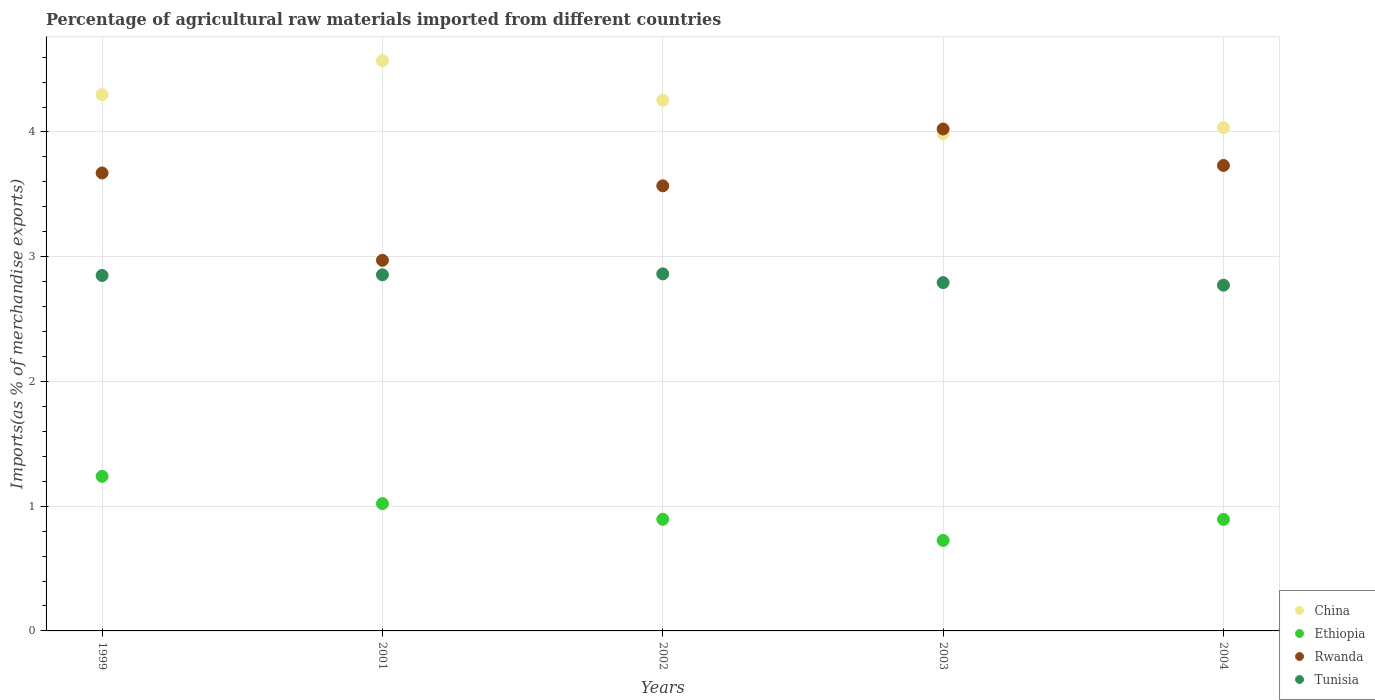How many different coloured dotlines are there?
Offer a very short reply. 4. Is the number of dotlines equal to the number of legend labels?
Provide a succinct answer. Yes. What is the percentage of imports to different countries in China in 2003?
Give a very brief answer. 3.99. Across all years, what is the maximum percentage of imports to different countries in China?
Your response must be concise. 4.57. Across all years, what is the minimum percentage of imports to different countries in Tunisia?
Your answer should be compact. 2.77. In which year was the percentage of imports to different countries in China minimum?
Keep it short and to the point. 2003. What is the total percentage of imports to different countries in Tunisia in the graph?
Give a very brief answer. 14.13. What is the difference between the percentage of imports to different countries in Tunisia in 2001 and that in 2003?
Offer a very short reply. 0.06. What is the difference between the percentage of imports to different countries in Ethiopia in 2003 and the percentage of imports to different countries in Tunisia in 1999?
Keep it short and to the point. -2.12. What is the average percentage of imports to different countries in Rwanda per year?
Your response must be concise. 3.59. In the year 2003, what is the difference between the percentage of imports to different countries in Ethiopia and percentage of imports to different countries in Tunisia?
Provide a short and direct response. -2.07. What is the ratio of the percentage of imports to different countries in Rwanda in 2001 to that in 2004?
Offer a very short reply. 0.8. What is the difference between the highest and the second highest percentage of imports to different countries in Tunisia?
Your response must be concise. 0.01. What is the difference between the highest and the lowest percentage of imports to different countries in Ethiopia?
Make the answer very short. 0.51. Is it the case that in every year, the sum of the percentage of imports to different countries in Tunisia and percentage of imports to different countries in Rwanda  is greater than the percentage of imports to different countries in China?
Your answer should be very brief. Yes. Is the percentage of imports to different countries in Tunisia strictly less than the percentage of imports to different countries in Ethiopia over the years?
Your answer should be compact. No. What is the title of the graph?
Offer a terse response. Percentage of agricultural raw materials imported from different countries. What is the label or title of the Y-axis?
Give a very brief answer. Imports(as % of merchandise exports). What is the Imports(as % of merchandise exports) in China in 1999?
Your answer should be very brief. 4.3. What is the Imports(as % of merchandise exports) in Ethiopia in 1999?
Provide a short and direct response. 1.24. What is the Imports(as % of merchandise exports) of Rwanda in 1999?
Make the answer very short. 3.67. What is the Imports(as % of merchandise exports) in Tunisia in 1999?
Offer a terse response. 2.85. What is the Imports(as % of merchandise exports) in China in 2001?
Make the answer very short. 4.57. What is the Imports(as % of merchandise exports) in Ethiopia in 2001?
Ensure brevity in your answer.  1.02. What is the Imports(as % of merchandise exports) of Rwanda in 2001?
Offer a very short reply. 2.97. What is the Imports(as % of merchandise exports) of Tunisia in 2001?
Keep it short and to the point. 2.85. What is the Imports(as % of merchandise exports) in China in 2002?
Provide a succinct answer. 4.25. What is the Imports(as % of merchandise exports) of Ethiopia in 2002?
Give a very brief answer. 0.89. What is the Imports(as % of merchandise exports) in Rwanda in 2002?
Make the answer very short. 3.57. What is the Imports(as % of merchandise exports) in Tunisia in 2002?
Provide a short and direct response. 2.86. What is the Imports(as % of merchandise exports) in China in 2003?
Give a very brief answer. 3.99. What is the Imports(as % of merchandise exports) in Ethiopia in 2003?
Offer a very short reply. 0.73. What is the Imports(as % of merchandise exports) of Rwanda in 2003?
Offer a terse response. 4.02. What is the Imports(as % of merchandise exports) in Tunisia in 2003?
Your response must be concise. 2.79. What is the Imports(as % of merchandise exports) in China in 2004?
Give a very brief answer. 4.03. What is the Imports(as % of merchandise exports) in Ethiopia in 2004?
Offer a very short reply. 0.89. What is the Imports(as % of merchandise exports) in Rwanda in 2004?
Provide a short and direct response. 3.73. What is the Imports(as % of merchandise exports) in Tunisia in 2004?
Ensure brevity in your answer.  2.77. Across all years, what is the maximum Imports(as % of merchandise exports) in China?
Give a very brief answer. 4.57. Across all years, what is the maximum Imports(as % of merchandise exports) in Ethiopia?
Your answer should be compact. 1.24. Across all years, what is the maximum Imports(as % of merchandise exports) in Rwanda?
Make the answer very short. 4.02. Across all years, what is the maximum Imports(as % of merchandise exports) in Tunisia?
Your answer should be compact. 2.86. Across all years, what is the minimum Imports(as % of merchandise exports) in China?
Provide a succinct answer. 3.99. Across all years, what is the minimum Imports(as % of merchandise exports) in Ethiopia?
Your answer should be compact. 0.73. Across all years, what is the minimum Imports(as % of merchandise exports) of Rwanda?
Provide a succinct answer. 2.97. Across all years, what is the minimum Imports(as % of merchandise exports) in Tunisia?
Your answer should be compact. 2.77. What is the total Imports(as % of merchandise exports) of China in the graph?
Make the answer very short. 21.15. What is the total Imports(as % of merchandise exports) in Ethiopia in the graph?
Give a very brief answer. 4.77. What is the total Imports(as % of merchandise exports) of Rwanda in the graph?
Your response must be concise. 17.97. What is the total Imports(as % of merchandise exports) of Tunisia in the graph?
Give a very brief answer. 14.13. What is the difference between the Imports(as % of merchandise exports) in China in 1999 and that in 2001?
Your answer should be very brief. -0.27. What is the difference between the Imports(as % of merchandise exports) of Ethiopia in 1999 and that in 2001?
Offer a terse response. 0.22. What is the difference between the Imports(as % of merchandise exports) of Rwanda in 1999 and that in 2001?
Your answer should be very brief. 0.7. What is the difference between the Imports(as % of merchandise exports) of Tunisia in 1999 and that in 2001?
Your response must be concise. -0.01. What is the difference between the Imports(as % of merchandise exports) in China in 1999 and that in 2002?
Provide a succinct answer. 0.05. What is the difference between the Imports(as % of merchandise exports) of Ethiopia in 1999 and that in 2002?
Provide a short and direct response. 0.34. What is the difference between the Imports(as % of merchandise exports) in Rwanda in 1999 and that in 2002?
Provide a succinct answer. 0.1. What is the difference between the Imports(as % of merchandise exports) in Tunisia in 1999 and that in 2002?
Give a very brief answer. -0.01. What is the difference between the Imports(as % of merchandise exports) in China in 1999 and that in 2003?
Give a very brief answer. 0.31. What is the difference between the Imports(as % of merchandise exports) of Ethiopia in 1999 and that in 2003?
Give a very brief answer. 0.51. What is the difference between the Imports(as % of merchandise exports) of Rwanda in 1999 and that in 2003?
Make the answer very short. -0.35. What is the difference between the Imports(as % of merchandise exports) of Tunisia in 1999 and that in 2003?
Provide a succinct answer. 0.06. What is the difference between the Imports(as % of merchandise exports) in China in 1999 and that in 2004?
Offer a very short reply. 0.27. What is the difference between the Imports(as % of merchandise exports) in Ethiopia in 1999 and that in 2004?
Your response must be concise. 0.34. What is the difference between the Imports(as % of merchandise exports) of Rwanda in 1999 and that in 2004?
Give a very brief answer. -0.06. What is the difference between the Imports(as % of merchandise exports) in Tunisia in 1999 and that in 2004?
Ensure brevity in your answer.  0.08. What is the difference between the Imports(as % of merchandise exports) of China in 2001 and that in 2002?
Keep it short and to the point. 0.32. What is the difference between the Imports(as % of merchandise exports) of Ethiopia in 2001 and that in 2002?
Offer a very short reply. 0.13. What is the difference between the Imports(as % of merchandise exports) in Rwanda in 2001 and that in 2002?
Provide a short and direct response. -0.6. What is the difference between the Imports(as % of merchandise exports) in Tunisia in 2001 and that in 2002?
Make the answer very short. -0.01. What is the difference between the Imports(as % of merchandise exports) of China in 2001 and that in 2003?
Provide a succinct answer. 0.59. What is the difference between the Imports(as % of merchandise exports) of Ethiopia in 2001 and that in 2003?
Your response must be concise. 0.29. What is the difference between the Imports(as % of merchandise exports) of Rwanda in 2001 and that in 2003?
Your answer should be compact. -1.05. What is the difference between the Imports(as % of merchandise exports) of Tunisia in 2001 and that in 2003?
Give a very brief answer. 0.06. What is the difference between the Imports(as % of merchandise exports) in China in 2001 and that in 2004?
Give a very brief answer. 0.54. What is the difference between the Imports(as % of merchandise exports) in Ethiopia in 2001 and that in 2004?
Your response must be concise. 0.13. What is the difference between the Imports(as % of merchandise exports) in Rwanda in 2001 and that in 2004?
Ensure brevity in your answer.  -0.76. What is the difference between the Imports(as % of merchandise exports) of Tunisia in 2001 and that in 2004?
Offer a very short reply. 0.08. What is the difference between the Imports(as % of merchandise exports) in China in 2002 and that in 2003?
Ensure brevity in your answer.  0.27. What is the difference between the Imports(as % of merchandise exports) of Ethiopia in 2002 and that in 2003?
Offer a terse response. 0.17. What is the difference between the Imports(as % of merchandise exports) in Rwanda in 2002 and that in 2003?
Give a very brief answer. -0.46. What is the difference between the Imports(as % of merchandise exports) in Tunisia in 2002 and that in 2003?
Ensure brevity in your answer.  0.07. What is the difference between the Imports(as % of merchandise exports) of China in 2002 and that in 2004?
Your response must be concise. 0.22. What is the difference between the Imports(as % of merchandise exports) in Ethiopia in 2002 and that in 2004?
Keep it short and to the point. 0. What is the difference between the Imports(as % of merchandise exports) of Rwanda in 2002 and that in 2004?
Keep it short and to the point. -0.16. What is the difference between the Imports(as % of merchandise exports) in Tunisia in 2002 and that in 2004?
Offer a very short reply. 0.09. What is the difference between the Imports(as % of merchandise exports) in China in 2003 and that in 2004?
Offer a terse response. -0.05. What is the difference between the Imports(as % of merchandise exports) of Ethiopia in 2003 and that in 2004?
Offer a very short reply. -0.17. What is the difference between the Imports(as % of merchandise exports) in Rwanda in 2003 and that in 2004?
Your response must be concise. 0.29. What is the difference between the Imports(as % of merchandise exports) in Tunisia in 2003 and that in 2004?
Give a very brief answer. 0.02. What is the difference between the Imports(as % of merchandise exports) in China in 1999 and the Imports(as % of merchandise exports) in Ethiopia in 2001?
Offer a terse response. 3.28. What is the difference between the Imports(as % of merchandise exports) in China in 1999 and the Imports(as % of merchandise exports) in Rwanda in 2001?
Offer a very short reply. 1.33. What is the difference between the Imports(as % of merchandise exports) of China in 1999 and the Imports(as % of merchandise exports) of Tunisia in 2001?
Ensure brevity in your answer.  1.44. What is the difference between the Imports(as % of merchandise exports) of Ethiopia in 1999 and the Imports(as % of merchandise exports) of Rwanda in 2001?
Offer a terse response. -1.73. What is the difference between the Imports(as % of merchandise exports) of Ethiopia in 1999 and the Imports(as % of merchandise exports) of Tunisia in 2001?
Keep it short and to the point. -1.62. What is the difference between the Imports(as % of merchandise exports) in Rwanda in 1999 and the Imports(as % of merchandise exports) in Tunisia in 2001?
Provide a succinct answer. 0.82. What is the difference between the Imports(as % of merchandise exports) of China in 1999 and the Imports(as % of merchandise exports) of Ethiopia in 2002?
Your response must be concise. 3.4. What is the difference between the Imports(as % of merchandise exports) in China in 1999 and the Imports(as % of merchandise exports) in Rwanda in 2002?
Your response must be concise. 0.73. What is the difference between the Imports(as % of merchandise exports) of China in 1999 and the Imports(as % of merchandise exports) of Tunisia in 2002?
Ensure brevity in your answer.  1.44. What is the difference between the Imports(as % of merchandise exports) in Ethiopia in 1999 and the Imports(as % of merchandise exports) in Rwanda in 2002?
Provide a succinct answer. -2.33. What is the difference between the Imports(as % of merchandise exports) of Ethiopia in 1999 and the Imports(as % of merchandise exports) of Tunisia in 2002?
Provide a succinct answer. -1.62. What is the difference between the Imports(as % of merchandise exports) of Rwanda in 1999 and the Imports(as % of merchandise exports) of Tunisia in 2002?
Offer a very short reply. 0.81. What is the difference between the Imports(as % of merchandise exports) of China in 1999 and the Imports(as % of merchandise exports) of Ethiopia in 2003?
Provide a short and direct response. 3.57. What is the difference between the Imports(as % of merchandise exports) in China in 1999 and the Imports(as % of merchandise exports) in Rwanda in 2003?
Your answer should be very brief. 0.28. What is the difference between the Imports(as % of merchandise exports) of China in 1999 and the Imports(as % of merchandise exports) of Tunisia in 2003?
Provide a succinct answer. 1.51. What is the difference between the Imports(as % of merchandise exports) in Ethiopia in 1999 and the Imports(as % of merchandise exports) in Rwanda in 2003?
Your answer should be compact. -2.78. What is the difference between the Imports(as % of merchandise exports) in Ethiopia in 1999 and the Imports(as % of merchandise exports) in Tunisia in 2003?
Provide a short and direct response. -1.55. What is the difference between the Imports(as % of merchandise exports) of Rwanda in 1999 and the Imports(as % of merchandise exports) of Tunisia in 2003?
Your answer should be compact. 0.88. What is the difference between the Imports(as % of merchandise exports) in China in 1999 and the Imports(as % of merchandise exports) in Ethiopia in 2004?
Your answer should be compact. 3.41. What is the difference between the Imports(as % of merchandise exports) in China in 1999 and the Imports(as % of merchandise exports) in Rwanda in 2004?
Give a very brief answer. 0.57. What is the difference between the Imports(as % of merchandise exports) in China in 1999 and the Imports(as % of merchandise exports) in Tunisia in 2004?
Keep it short and to the point. 1.53. What is the difference between the Imports(as % of merchandise exports) of Ethiopia in 1999 and the Imports(as % of merchandise exports) of Rwanda in 2004?
Your answer should be very brief. -2.49. What is the difference between the Imports(as % of merchandise exports) in Ethiopia in 1999 and the Imports(as % of merchandise exports) in Tunisia in 2004?
Ensure brevity in your answer.  -1.53. What is the difference between the Imports(as % of merchandise exports) in Rwanda in 1999 and the Imports(as % of merchandise exports) in Tunisia in 2004?
Give a very brief answer. 0.9. What is the difference between the Imports(as % of merchandise exports) in China in 2001 and the Imports(as % of merchandise exports) in Ethiopia in 2002?
Ensure brevity in your answer.  3.68. What is the difference between the Imports(as % of merchandise exports) in China in 2001 and the Imports(as % of merchandise exports) in Rwanda in 2002?
Ensure brevity in your answer.  1. What is the difference between the Imports(as % of merchandise exports) of China in 2001 and the Imports(as % of merchandise exports) of Tunisia in 2002?
Keep it short and to the point. 1.71. What is the difference between the Imports(as % of merchandise exports) of Ethiopia in 2001 and the Imports(as % of merchandise exports) of Rwanda in 2002?
Ensure brevity in your answer.  -2.55. What is the difference between the Imports(as % of merchandise exports) in Ethiopia in 2001 and the Imports(as % of merchandise exports) in Tunisia in 2002?
Keep it short and to the point. -1.84. What is the difference between the Imports(as % of merchandise exports) of Rwanda in 2001 and the Imports(as % of merchandise exports) of Tunisia in 2002?
Provide a succinct answer. 0.11. What is the difference between the Imports(as % of merchandise exports) in China in 2001 and the Imports(as % of merchandise exports) in Ethiopia in 2003?
Provide a succinct answer. 3.85. What is the difference between the Imports(as % of merchandise exports) of China in 2001 and the Imports(as % of merchandise exports) of Rwanda in 2003?
Ensure brevity in your answer.  0.55. What is the difference between the Imports(as % of merchandise exports) in China in 2001 and the Imports(as % of merchandise exports) in Tunisia in 2003?
Offer a terse response. 1.78. What is the difference between the Imports(as % of merchandise exports) in Ethiopia in 2001 and the Imports(as % of merchandise exports) in Rwanda in 2003?
Keep it short and to the point. -3. What is the difference between the Imports(as % of merchandise exports) in Ethiopia in 2001 and the Imports(as % of merchandise exports) in Tunisia in 2003?
Keep it short and to the point. -1.77. What is the difference between the Imports(as % of merchandise exports) of Rwanda in 2001 and the Imports(as % of merchandise exports) of Tunisia in 2003?
Ensure brevity in your answer.  0.18. What is the difference between the Imports(as % of merchandise exports) in China in 2001 and the Imports(as % of merchandise exports) in Ethiopia in 2004?
Ensure brevity in your answer.  3.68. What is the difference between the Imports(as % of merchandise exports) of China in 2001 and the Imports(as % of merchandise exports) of Rwanda in 2004?
Your answer should be very brief. 0.84. What is the difference between the Imports(as % of merchandise exports) of China in 2001 and the Imports(as % of merchandise exports) of Tunisia in 2004?
Ensure brevity in your answer.  1.8. What is the difference between the Imports(as % of merchandise exports) of Ethiopia in 2001 and the Imports(as % of merchandise exports) of Rwanda in 2004?
Keep it short and to the point. -2.71. What is the difference between the Imports(as % of merchandise exports) of Ethiopia in 2001 and the Imports(as % of merchandise exports) of Tunisia in 2004?
Provide a succinct answer. -1.75. What is the difference between the Imports(as % of merchandise exports) of Rwanda in 2001 and the Imports(as % of merchandise exports) of Tunisia in 2004?
Offer a very short reply. 0.2. What is the difference between the Imports(as % of merchandise exports) in China in 2002 and the Imports(as % of merchandise exports) in Ethiopia in 2003?
Provide a succinct answer. 3.53. What is the difference between the Imports(as % of merchandise exports) of China in 2002 and the Imports(as % of merchandise exports) of Rwanda in 2003?
Your answer should be very brief. 0.23. What is the difference between the Imports(as % of merchandise exports) of China in 2002 and the Imports(as % of merchandise exports) of Tunisia in 2003?
Provide a short and direct response. 1.46. What is the difference between the Imports(as % of merchandise exports) of Ethiopia in 2002 and the Imports(as % of merchandise exports) of Rwanda in 2003?
Your answer should be compact. -3.13. What is the difference between the Imports(as % of merchandise exports) of Ethiopia in 2002 and the Imports(as % of merchandise exports) of Tunisia in 2003?
Ensure brevity in your answer.  -1.9. What is the difference between the Imports(as % of merchandise exports) in Rwanda in 2002 and the Imports(as % of merchandise exports) in Tunisia in 2003?
Offer a very short reply. 0.78. What is the difference between the Imports(as % of merchandise exports) in China in 2002 and the Imports(as % of merchandise exports) in Ethiopia in 2004?
Provide a short and direct response. 3.36. What is the difference between the Imports(as % of merchandise exports) in China in 2002 and the Imports(as % of merchandise exports) in Rwanda in 2004?
Make the answer very short. 0.52. What is the difference between the Imports(as % of merchandise exports) in China in 2002 and the Imports(as % of merchandise exports) in Tunisia in 2004?
Offer a terse response. 1.48. What is the difference between the Imports(as % of merchandise exports) in Ethiopia in 2002 and the Imports(as % of merchandise exports) in Rwanda in 2004?
Provide a short and direct response. -2.84. What is the difference between the Imports(as % of merchandise exports) of Ethiopia in 2002 and the Imports(as % of merchandise exports) of Tunisia in 2004?
Your answer should be very brief. -1.88. What is the difference between the Imports(as % of merchandise exports) of Rwanda in 2002 and the Imports(as % of merchandise exports) of Tunisia in 2004?
Offer a terse response. 0.8. What is the difference between the Imports(as % of merchandise exports) in China in 2003 and the Imports(as % of merchandise exports) in Ethiopia in 2004?
Your answer should be very brief. 3.09. What is the difference between the Imports(as % of merchandise exports) of China in 2003 and the Imports(as % of merchandise exports) of Rwanda in 2004?
Keep it short and to the point. 0.25. What is the difference between the Imports(as % of merchandise exports) in China in 2003 and the Imports(as % of merchandise exports) in Tunisia in 2004?
Your response must be concise. 1.21. What is the difference between the Imports(as % of merchandise exports) of Ethiopia in 2003 and the Imports(as % of merchandise exports) of Rwanda in 2004?
Provide a short and direct response. -3.01. What is the difference between the Imports(as % of merchandise exports) of Ethiopia in 2003 and the Imports(as % of merchandise exports) of Tunisia in 2004?
Provide a short and direct response. -2.05. What is the difference between the Imports(as % of merchandise exports) of Rwanda in 2003 and the Imports(as % of merchandise exports) of Tunisia in 2004?
Provide a short and direct response. 1.25. What is the average Imports(as % of merchandise exports) in China per year?
Give a very brief answer. 4.23. What is the average Imports(as % of merchandise exports) in Ethiopia per year?
Offer a terse response. 0.95. What is the average Imports(as % of merchandise exports) in Rwanda per year?
Give a very brief answer. 3.59. What is the average Imports(as % of merchandise exports) in Tunisia per year?
Your answer should be compact. 2.83. In the year 1999, what is the difference between the Imports(as % of merchandise exports) of China and Imports(as % of merchandise exports) of Ethiopia?
Your answer should be compact. 3.06. In the year 1999, what is the difference between the Imports(as % of merchandise exports) of China and Imports(as % of merchandise exports) of Rwanda?
Provide a succinct answer. 0.63. In the year 1999, what is the difference between the Imports(as % of merchandise exports) of China and Imports(as % of merchandise exports) of Tunisia?
Your answer should be very brief. 1.45. In the year 1999, what is the difference between the Imports(as % of merchandise exports) of Ethiopia and Imports(as % of merchandise exports) of Rwanda?
Your response must be concise. -2.43. In the year 1999, what is the difference between the Imports(as % of merchandise exports) in Ethiopia and Imports(as % of merchandise exports) in Tunisia?
Your answer should be compact. -1.61. In the year 1999, what is the difference between the Imports(as % of merchandise exports) of Rwanda and Imports(as % of merchandise exports) of Tunisia?
Your answer should be compact. 0.82. In the year 2001, what is the difference between the Imports(as % of merchandise exports) in China and Imports(as % of merchandise exports) in Ethiopia?
Provide a short and direct response. 3.55. In the year 2001, what is the difference between the Imports(as % of merchandise exports) of China and Imports(as % of merchandise exports) of Rwanda?
Give a very brief answer. 1.6. In the year 2001, what is the difference between the Imports(as % of merchandise exports) in China and Imports(as % of merchandise exports) in Tunisia?
Ensure brevity in your answer.  1.72. In the year 2001, what is the difference between the Imports(as % of merchandise exports) in Ethiopia and Imports(as % of merchandise exports) in Rwanda?
Make the answer very short. -1.95. In the year 2001, what is the difference between the Imports(as % of merchandise exports) in Ethiopia and Imports(as % of merchandise exports) in Tunisia?
Your answer should be compact. -1.83. In the year 2001, what is the difference between the Imports(as % of merchandise exports) of Rwanda and Imports(as % of merchandise exports) of Tunisia?
Make the answer very short. 0.12. In the year 2002, what is the difference between the Imports(as % of merchandise exports) of China and Imports(as % of merchandise exports) of Ethiopia?
Keep it short and to the point. 3.36. In the year 2002, what is the difference between the Imports(as % of merchandise exports) of China and Imports(as % of merchandise exports) of Rwanda?
Provide a short and direct response. 0.69. In the year 2002, what is the difference between the Imports(as % of merchandise exports) in China and Imports(as % of merchandise exports) in Tunisia?
Provide a succinct answer. 1.39. In the year 2002, what is the difference between the Imports(as % of merchandise exports) of Ethiopia and Imports(as % of merchandise exports) of Rwanda?
Ensure brevity in your answer.  -2.67. In the year 2002, what is the difference between the Imports(as % of merchandise exports) in Ethiopia and Imports(as % of merchandise exports) in Tunisia?
Your answer should be compact. -1.97. In the year 2002, what is the difference between the Imports(as % of merchandise exports) of Rwanda and Imports(as % of merchandise exports) of Tunisia?
Make the answer very short. 0.71. In the year 2003, what is the difference between the Imports(as % of merchandise exports) of China and Imports(as % of merchandise exports) of Ethiopia?
Provide a succinct answer. 3.26. In the year 2003, what is the difference between the Imports(as % of merchandise exports) of China and Imports(as % of merchandise exports) of Rwanda?
Your answer should be compact. -0.04. In the year 2003, what is the difference between the Imports(as % of merchandise exports) of China and Imports(as % of merchandise exports) of Tunisia?
Ensure brevity in your answer.  1.19. In the year 2003, what is the difference between the Imports(as % of merchandise exports) in Ethiopia and Imports(as % of merchandise exports) in Rwanda?
Give a very brief answer. -3.3. In the year 2003, what is the difference between the Imports(as % of merchandise exports) in Ethiopia and Imports(as % of merchandise exports) in Tunisia?
Offer a terse response. -2.07. In the year 2003, what is the difference between the Imports(as % of merchandise exports) of Rwanda and Imports(as % of merchandise exports) of Tunisia?
Provide a succinct answer. 1.23. In the year 2004, what is the difference between the Imports(as % of merchandise exports) of China and Imports(as % of merchandise exports) of Ethiopia?
Offer a terse response. 3.14. In the year 2004, what is the difference between the Imports(as % of merchandise exports) in China and Imports(as % of merchandise exports) in Rwanda?
Provide a succinct answer. 0.3. In the year 2004, what is the difference between the Imports(as % of merchandise exports) in China and Imports(as % of merchandise exports) in Tunisia?
Your response must be concise. 1.26. In the year 2004, what is the difference between the Imports(as % of merchandise exports) of Ethiopia and Imports(as % of merchandise exports) of Rwanda?
Offer a very short reply. -2.84. In the year 2004, what is the difference between the Imports(as % of merchandise exports) in Ethiopia and Imports(as % of merchandise exports) in Tunisia?
Your answer should be compact. -1.88. In the year 2004, what is the difference between the Imports(as % of merchandise exports) in Rwanda and Imports(as % of merchandise exports) in Tunisia?
Your answer should be compact. 0.96. What is the ratio of the Imports(as % of merchandise exports) in China in 1999 to that in 2001?
Offer a very short reply. 0.94. What is the ratio of the Imports(as % of merchandise exports) in Ethiopia in 1999 to that in 2001?
Your answer should be very brief. 1.21. What is the ratio of the Imports(as % of merchandise exports) in Rwanda in 1999 to that in 2001?
Provide a succinct answer. 1.24. What is the ratio of the Imports(as % of merchandise exports) in China in 1999 to that in 2002?
Make the answer very short. 1.01. What is the ratio of the Imports(as % of merchandise exports) of Ethiopia in 1999 to that in 2002?
Offer a very short reply. 1.38. What is the ratio of the Imports(as % of merchandise exports) of Rwanda in 1999 to that in 2002?
Make the answer very short. 1.03. What is the ratio of the Imports(as % of merchandise exports) of Tunisia in 1999 to that in 2002?
Ensure brevity in your answer.  1. What is the ratio of the Imports(as % of merchandise exports) in China in 1999 to that in 2003?
Offer a very short reply. 1.08. What is the ratio of the Imports(as % of merchandise exports) of Ethiopia in 1999 to that in 2003?
Provide a short and direct response. 1.71. What is the ratio of the Imports(as % of merchandise exports) of Rwanda in 1999 to that in 2003?
Your response must be concise. 0.91. What is the ratio of the Imports(as % of merchandise exports) in Tunisia in 1999 to that in 2003?
Your answer should be very brief. 1.02. What is the ratio of the Imports(as % of merchandise exports) in China in 1999 to that in 2004?
Make the answer very short. 1.07. What is the ratio of the Imports(as % of merchandise exports) in Ethiopia in 1999 to that in 2004?
Provide a succinct answer. 1.39. What is the ratio of the Imports(as % of merchandise exports) in Rwanda in 1999 to that in 2004?
Provide a succinct answer. 0.98. What is the ratio of the Imports(as % of merchandise exports) in Tunisia in 1999 to that in 2004?
Offer a very short reply. 1.03. What is the ratio of the Imports(as % of merchandise exports) in China in 2001 to that in 2002?
Offer a very short reply. 1.07. What is the ratio of the Imports(as % of merchandise exports) in Ethiopia in 2001 to that in 2002?
Offer a very short reply. 1.14. What is the ratio of the Imports(as % of merchandise exports) in Rwanda in 2001 to that in 2002?
Your response must be concise. 0.83. What is the ratio of the Imports(as % of merchandise exports) in China in 2001 to that in 2003?
Offer a terse response. 1.15. What is the ratio of the Imports(as % of merchandise exports) of Ethiopia in 2001 to that in 2003?
Your answer should be very brief. 1.41. What is the ratio of the Imports(as % of merchandise exports) in Rwanda in 2001 to that in 2003?
Ensure brevity in your answer.  0.74. What is the ratio of the Imports(as % of merchandise exports) in Tunisia in 2001 to that in 2003?
Your response must be concise. 1.02. What is the ratio of the Imports(as % of merchandise exports) of China in 2001 to that in 2004?
Make the answer very short. 1.13. What is the ratio of the Imports(as % of merchandise exports) in Ethiopia in 2001 to that in 2004?
Offer a terse response. 1.14. What is the ratio of the Imports(as % of merchandise exports) of Rwanda in 2001 to that in 2004?
Provide a short and direct response. 0.8. What is the ratio of the Imports(as % of merchandise exports) of China in 2002 to that in 2003?
Give a very brief answer. 1.07. What is the ratio of the Imports(as % of merchandise exports) of Ethiopia in 2002 to that in 2003?
Provide a succinct answer. 1.23. What is the ratio of the Imports(as % of merchandise exports) of Rwanda in 2002 to that in 2003?
Your answer should be compact. 0.89. What is the ratio of the Imports(as % of merchandise exports) of Tunisia in 2002 to that in 2003?
Offer a terse response. 1.02. What is the ratio of the Imports(as % of merchandise exports) of China in 2002 to that in 2004?
Provide a succinct answer. 1.05. What is the ratio of the Imports(as % of merchandise exports) of Ethiopia in 2002 to that in 2004?
Make the answer very short. 1. What is the ratio of the Imports(as % of merchandise exports) of Rwanda in 2002 to that in 2004?
Your answer should be very brief. 0.96. What is the ratio of the Imports(as % of merchandise exports) in Tunisia in 2002 to that in 2004?
Your response must be concise. 1.03. What is the ratio of the Imports(as % of merchandise exports) of Ethiopia in 2003 to that in 2004?
Provide a succinct answer. 0.81. What is the ratio of the Imports(as % of merchandise exports) in Rwanda in 2003 to that in 2004?
Your answer should be compact. 1.08. What is the ratio of the Imports(as % of merchandise exports) in Tunisia in 2003 to that in 2004?
Make the answer very short. 1.01. What is the difference between the highest and the second highest Imports(as % of merchandise exports) of China?
Keep it short and to the point. 0.27. What is the difference between the highest and the second highest Imports(as % of merchandise exports) of Ethiopia?
Your answer should be very brief. 0.22. What is the difference between the highest and the second highest Imports(as % of merchandise exports) of Rwanda?
Make the answer very short. 0.29. What is the difference between the highest and the second highest Imports(as % of merchandise exports) of Tunisia?
Make the answer very short. 0.01. What is the difference between the highest and the lowest Imports(as % of merchandise exports) in China?
Keep it short and to the point. 0.59. What is the difference between the highest and the lowest Imports(as % of merchandise exports) of Ethiopia?
Your answer should be compact. 0.51. What is the difference between the highest and the lowest Imports(as % of merchandise exports) in Rwanda?
Keep it short and to the point. 1.05. What is the difference between the highest and the lowest Imports(as % of merchandise exports) in Tunisia?
Ensure brevity in your answer.  0.09. 